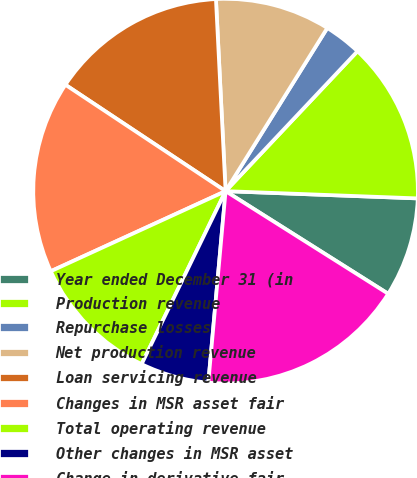Convert chart. <chart><loc_0><loc_0><loc_500><loc_500><pie_chart><fcel>Year ended December 31 (in<fcel>Production revenue<fcel>Repurchase losses<fcel>Net production revenue<fcel>Loan servicing revenue<fcel>Changes in MSR asset fair<fcel>Total operating revenue<fcel>Other changes in MSR asset<fcel>Change in derivative fair<nl><fcel>8.36%<fcel>13.57%<fcel>3.16%<fcel>9.67%<fcel>14.87%<fcel>16.17%<fcel>10.97%<fcel>5.76%<fcel>17.47%<nl></chart> 